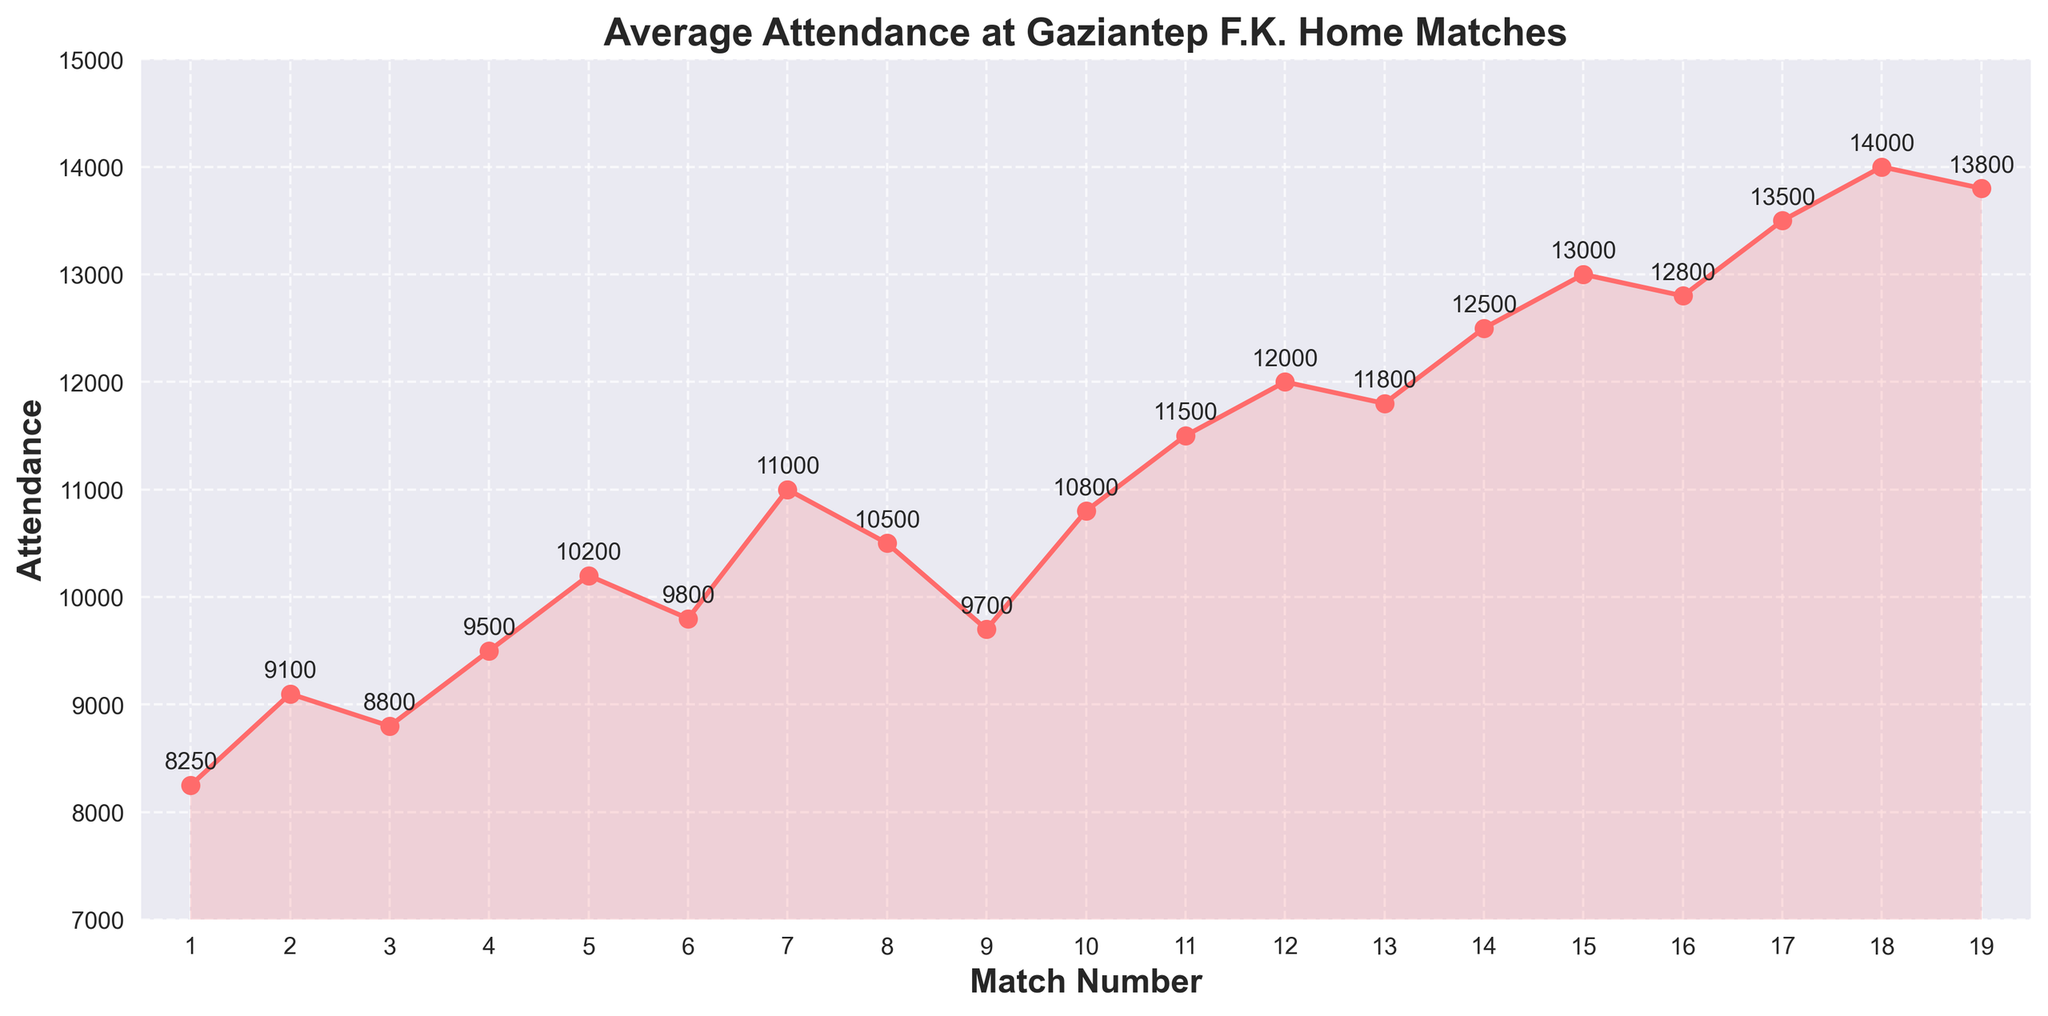What is the lowest attendance recorded across the season? To find the lowest attendance, check the graph for the minimum value marked by dots. The first match has the lowest dot on the y-axis.
Answer: 8250 When did the attendance first exceed 10,000? Find the point on the x-axis where the attendance crosses the 10,000 mark on the y-axis. Match 5 has attendance surpassing 10,000.
Answer: Match 5 What was the average attendance between Match 10 and Match 15? Calculate the average by summing the attendances from Match 10 to Match 15 and dividing by the number of matches: (10800 + 11500 + 12000 + 11800 + 12500 + 13000)/6.
Answer: 11933.33 How many times did the attendance drop compared to the previous match? Examine how often the line chart dips between matches. The attendance drops between Matches 3-4, 6-7, and 8-9.
Answer: 3 Which match had the highest attendance? Identify the highest point on the y-axis. Match 18 has the highest attendance.
Answer: Match 18 Did the attendance trend generally increase or decrease throughout the season? Assess the general slope of the line. Although there are dips, the line generally trends upwards.
Answer: Increase Compare the attendance of Match 5 and Match 15. Which match had higher attendance? Compare the y-values for Match 5 and Match 15. Match 15 has an attendance of 13,000, higher than Match 5's 10,200.
Answer: Match 15 By how much did the attendance increase from Match 1 to Match 19? Subtract the attendance at Match 1 from the attendance at Match 19. (13800 - 8250).
Answer: 5550 What was the total attendance over the season? Sum all the attendance numbers from all matches. The sum is 220,050.
Answer: 220050 